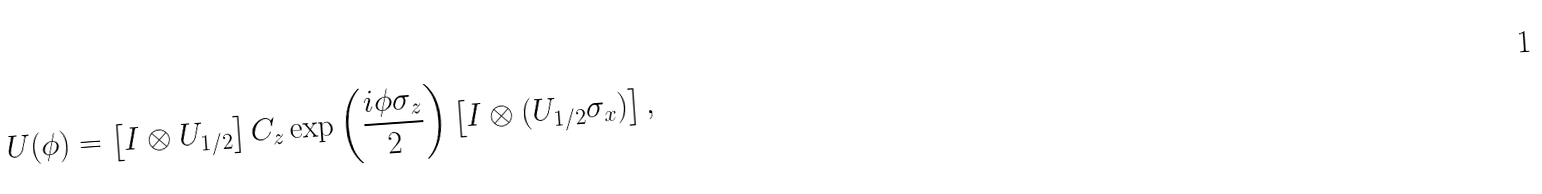Convert formula to latex. <formula><loc_0><loc_0><loc_500><loc_500>U ( \phi ) = \left [ I \otimes U _ { 1 / 2 } \right ] C _ { z } \exp \left ( \frac { i \phi \sigma _ { z } } { 2 } \right ) \left [ I \otimes ( U _ { 1 / 2 } \sigma _ { x } ) \right ] ,</formula> 